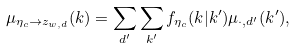<formula> <loc_0><loc_0><loc_500><loc_500>\mu _ { \eta _ { c } \rightarrow z _ { w , d } } ( k ) = \sum _ { d ^ { \prime } } \sum _ { k ^ { \prime } } f _ { \eta _ { c } } ( k | k ^ { \prime } ) \mu _ { \cdot , d ^ { \prime } } ( k ^ { \prime } ) ,</formula> 